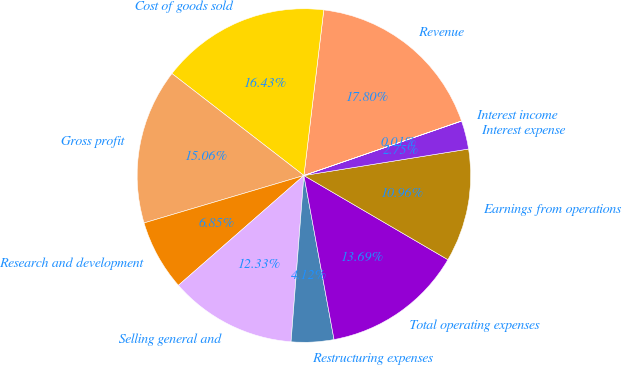Convert chart. <chart><loc_0><loc_0><loc_500><loc_500><pie_chart><fcel>Revenue<fcel>Cost of goods sold<fcel>Gross profit<fcel>Research and development<fcel>Selling general and<fcel>Restructuring expenses<fcel>Total operating expenses<fcel>Earnings from operations<fcel>Interest expense<fcel>Interest income<nl><fcel>17.8%<fcel>16.43%<fcel>15.06%<fcel>6.85%<fcel>12.33%<fcel>4.12%<fcel>13.69%<fcel>10.96%<fcel>2.75%<fcel>0.01%<nl></chart> 